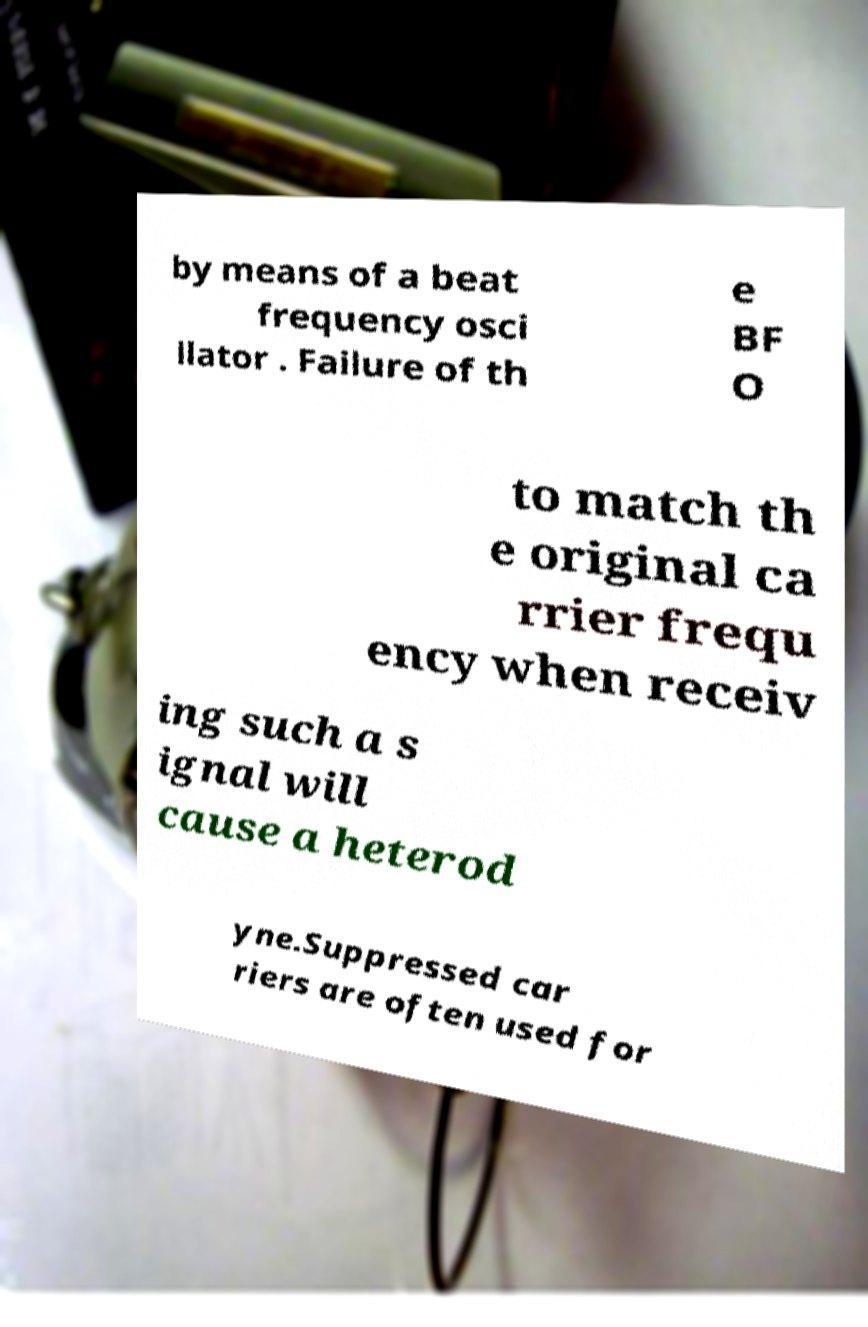There's text embedded in this image that I need extracted. Can you transcribe it verbatim? by means of a beat frequency osci llator . Failure of th e BF O to match th e original ca rrier frequ ency when receiv ing such a s ignal will cause a heterod yne.Suppressed car riers are often used for 